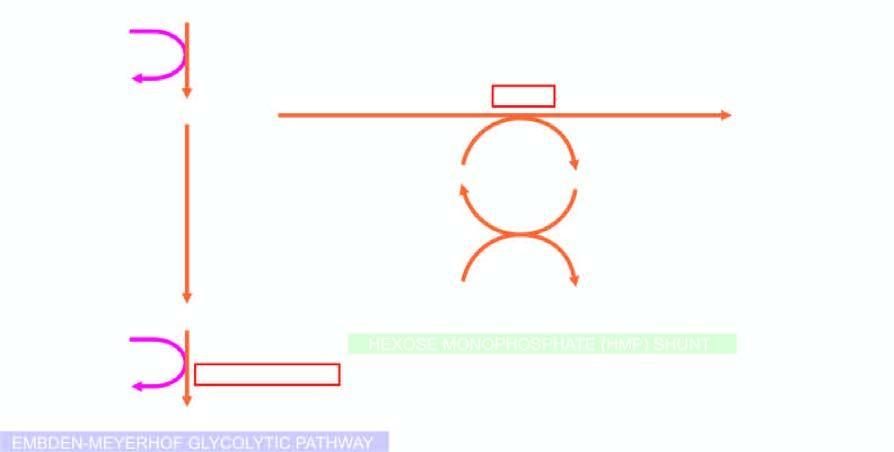re other components of virion shown bold?
Answer the question using a single word or phrase. No 